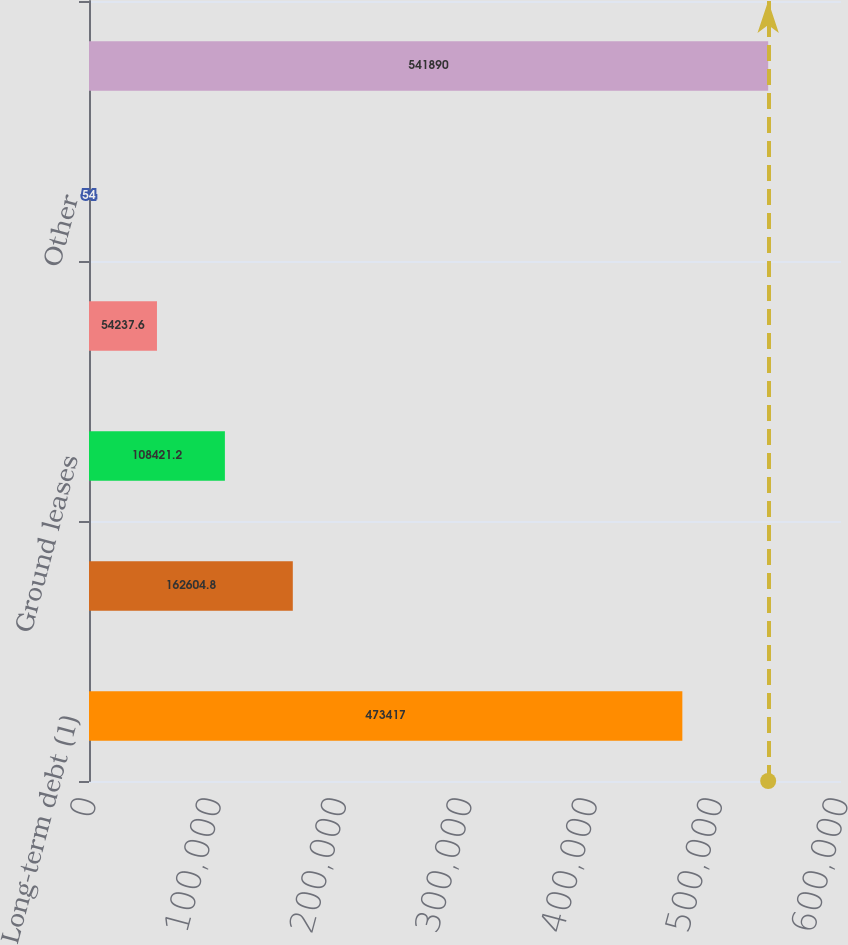Convert chart to OTSL. <chart><loc_0><loc_0><loc_500><loc_500><bar_chart><fcel>Long-term debt (1)<fcel>Share of debt of<fcel>Ground leases<fcel>Operating leases<fcel>Other<fcel>Total Contractual Obligations<nl><fcel>473417<fcel>162605<fcel>108421<fcel>54237.6<fcel>54<fcel>541890<nl></chart> 